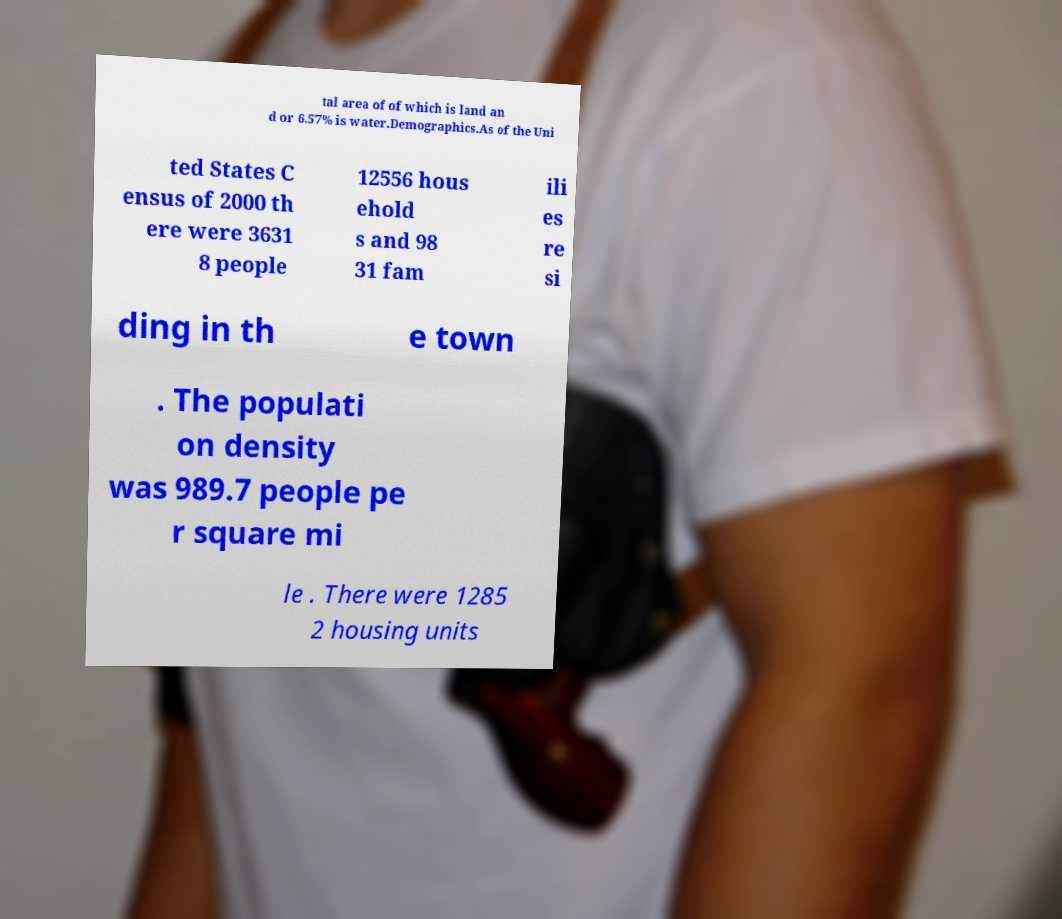I need the written content from this picture converted into text. Can you do that? tal area of of which is land an d or 6.57% is water.Demographics.As of the Uni ted States C ensus of 2000 th ere were 3631 8 people 12556 hous ehold s and 98 31 fam ili es re si ding in th e town . The populati on density was 989.7 people pe r square mi le . There were 1285 2 housing units 